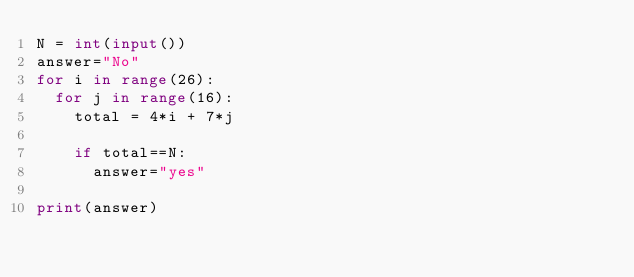<code> <loc_0><loc_0><loc_500><loc_500><_Python_>N = int(input())
answer="No"
for i in range(26):
  for j in range(16):
    total = 4*i + 7*j
    
    if total==N:
      answer="yes"

print(answer)</code> 